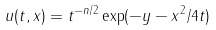Convert formula to latex. <formula><loc_0><loc_0><loc_500><loc_500>u ( t , x ) = t ^ { - n / 2 } \exp ( - \| y - x \| ^ { 2 } / 4 t )</formula> 